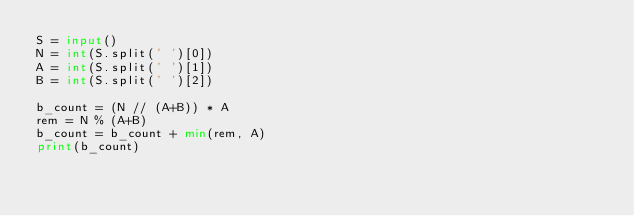<code> <loc_0><loc_0><loc_500><loc_500><_Python_>S = input()
N = int(S.split(' ')[0])
A = int(S.split(' ')[1])
B = int(S.split(' ')[2])
 
b_count = (N // (A+B)) * A
rem = N % (A+B)
b_count = b_count + min(rem, A)
print(b_count)</code> 